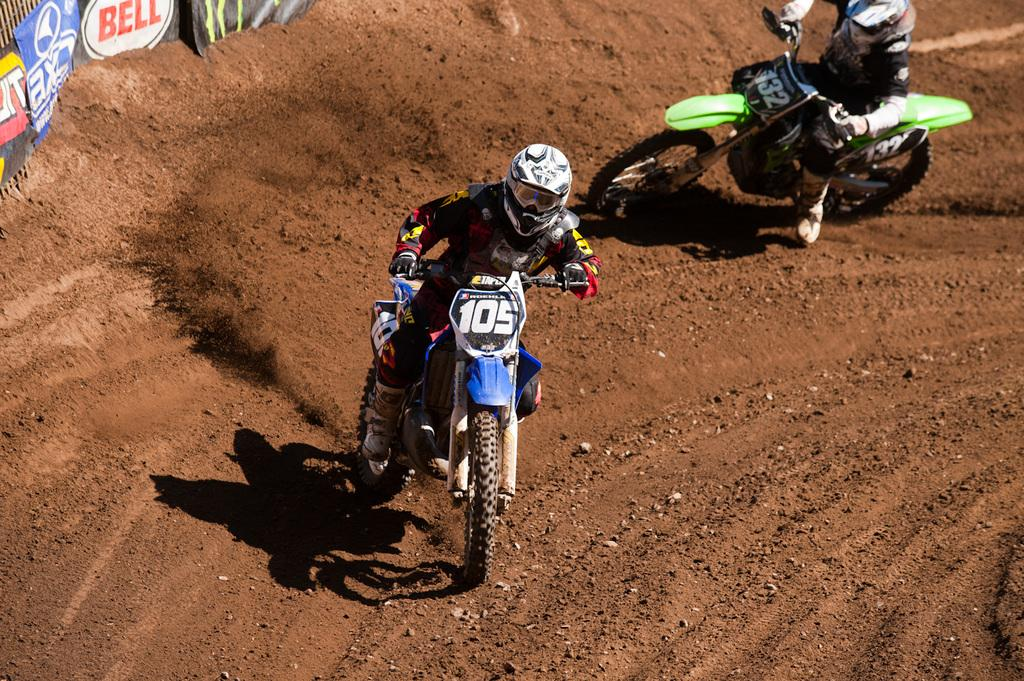How many people are in the image? There are two people in the image. What are the two people doing in the image? The two people are riding motorcycles. What can be seen on the left side of the image? There are banners on the left side of the image. What type of soup is being served at the event depicted by the banners? There is no mention of soup or an event in the image, so it cannot be determined from the facts. 